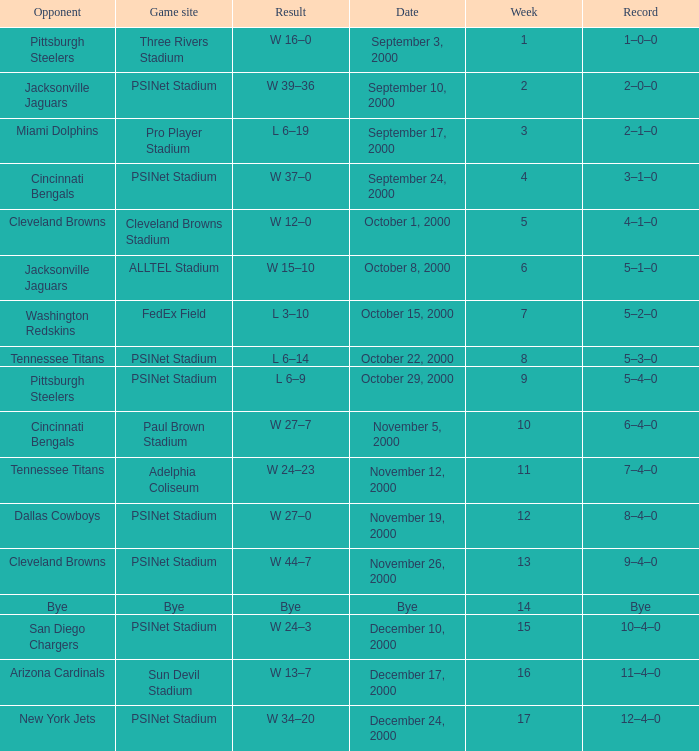What game site has a result of bye? Bye. 